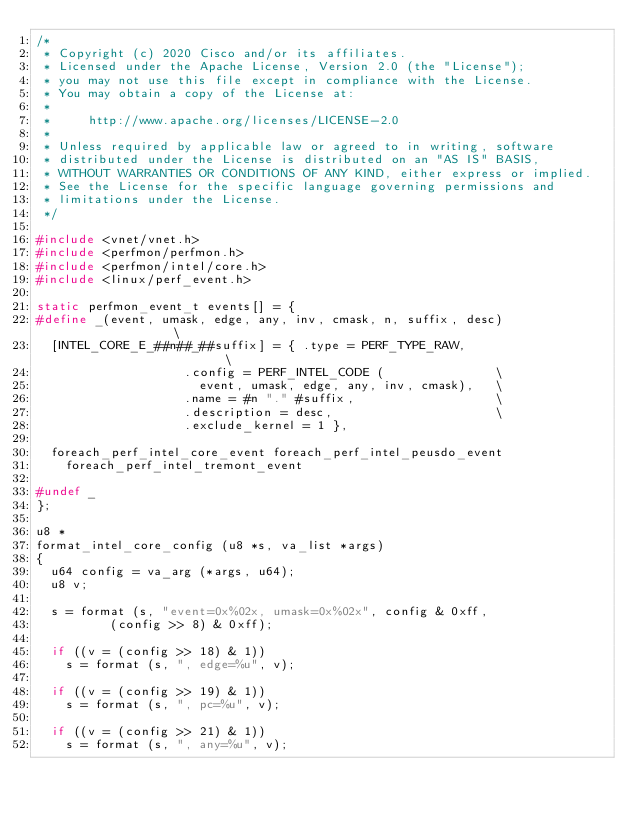<code> <loc_0><loc_0><loc_500><loc_500><_C_>/*
 * Copyright (c) 2020 Cisco and/or its affiliates.
 * Licensed under the Apache License, Version 2.0 (the "License");
 * you may not use this file except in compliance with the License.
 * You may obtain a copy of the License at:
 *
 *     http://www.apache.org/licenses/LICENSE-2.0
 *
 * Unless required by applicable law or agreed to in writing, software
 * distributed under the License is distributed on an "AS IS" BASIS,
 * WITHOUT WARRANTIES OR CONDITIONS OF ANY KIND, either express or implied.
 * See the License for the specific language governing permissions and
 * limitations under the License.
 */

#include <vnet/vnet.h>
#include <perfmon/perfmon.h>
#include <perfmon/intel/core.h>
#include <linux/perf_event.h>

static perfmon_event_t events[] = {
#define _(event, umask, edge, any, inv, cmask, n, suffix, desc)               \
  [INTEL_CORE_E_##n##_##suffix] = { .type = PERF_TYPE_RAW,                    \
				    .config = PERF_INTEL_CODE (               \
				      event, umask, edge, any, inv, cmask),   \
				    .name = #n "." #suffix,                   \
				    .description = desc,                      \
				    .exclude_kernel = 1 },

  foreach_perf_intel_core_event foreach_perf_intel_peusdo_event
    foreach_perf_intel_tremont_event

#undef _
};

u8 *
format_intel_core_config (u8 *s, va_list *args)
{
  u64 config = va_arg (*args, u64);
  u8 v;

  s = format (s, "event=0x%02x, umask=0x%02x", config & 0xff,
	      (config >> 8) & 0xff);

  if ((v = (config >> 18) & 1))
    s = format (s, ", edge=%u", v);

  if ((v = (config >> 19) & 1))
    s = format (s, ", pc=%u", v);

  if ((v = (config >> 21) & 1))
    s = format (s, ", any=%u", v);
</code> 